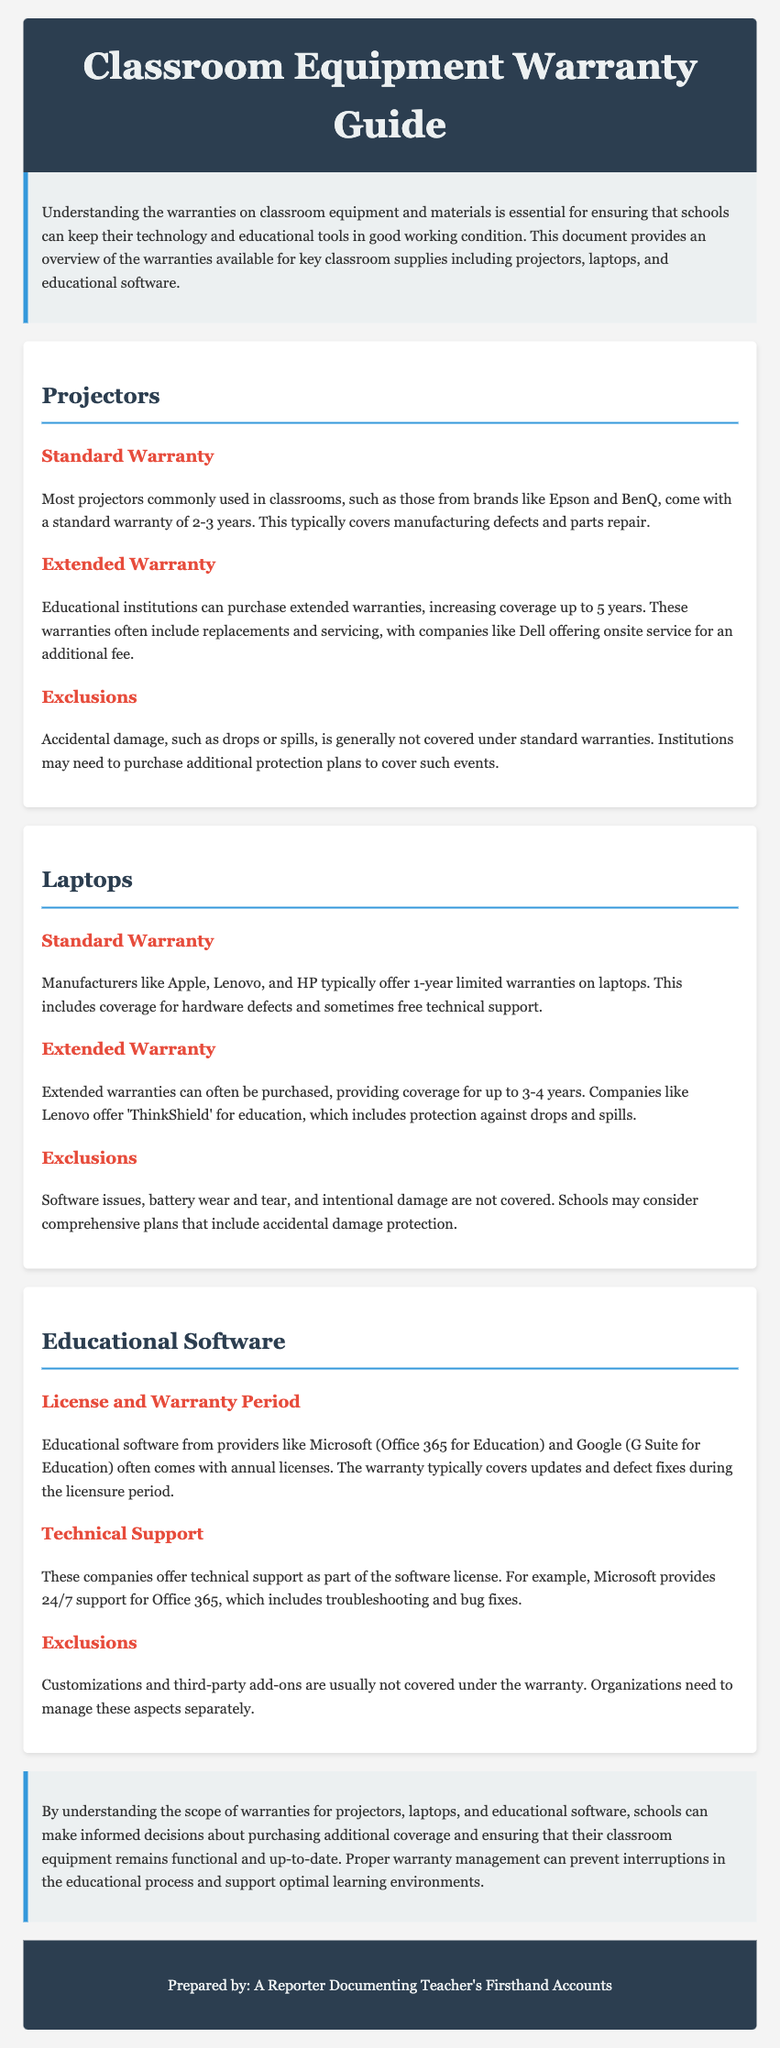What is the standard warranty for projectors? The standard warranty for projectors commonly used in classrooms is typically 2-3 years.
Answer: 2-3 years Which companies offer extended warranties for projectors? Companies like Dell offer onsite service that can be purchased as part of extended warranties for projectors.
Answer: Dell What is the warranty coverage period for laptops from manufacturers like Apple? Manufacturers like Apple typically offer a standard 1-year limited warranty on laptops.
Answer: 1 year What does Lenovo's 'ThinkShield' warranty include? Lenovo's 'ThinkShield' for education includes protection against drops and spills.
Answer: Protection against drops and spills What type of support do educational software providers like Microsoft offer? Microsoft provides 24/7 support for Office 365, which includes troubleshooting and bug fixes.
Answer: 24/7 support What is typically not covered under the standard warranty for projectors? Accidental damage, such as drops or spills, is generally not covered under standard warranties.
Answer: Accidental damage What component is commonly excluded from coverage in laptop warranties? Software issues are commonly excluded from coverage in laptop warranties.
Answer: Software issues What is provided during the warranty period for educational software licenses? The warranty typically covers updates and defect fixes during the licensure period.
Answer: Updates and defect fixes What is a common exclusion for warranties on educational software? Customizations and third-party add-ons are usually not covered under the warranty.
Answer: Customizations and third-party add-ons 